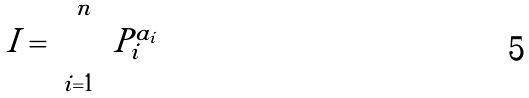Convert formula to latex. <formula><loc_0><loc_0><loc_500><loc_500>I = \prod _ { i = 1 } ^ { n } P _ { i } ^ { a _ { i } }</formula> 